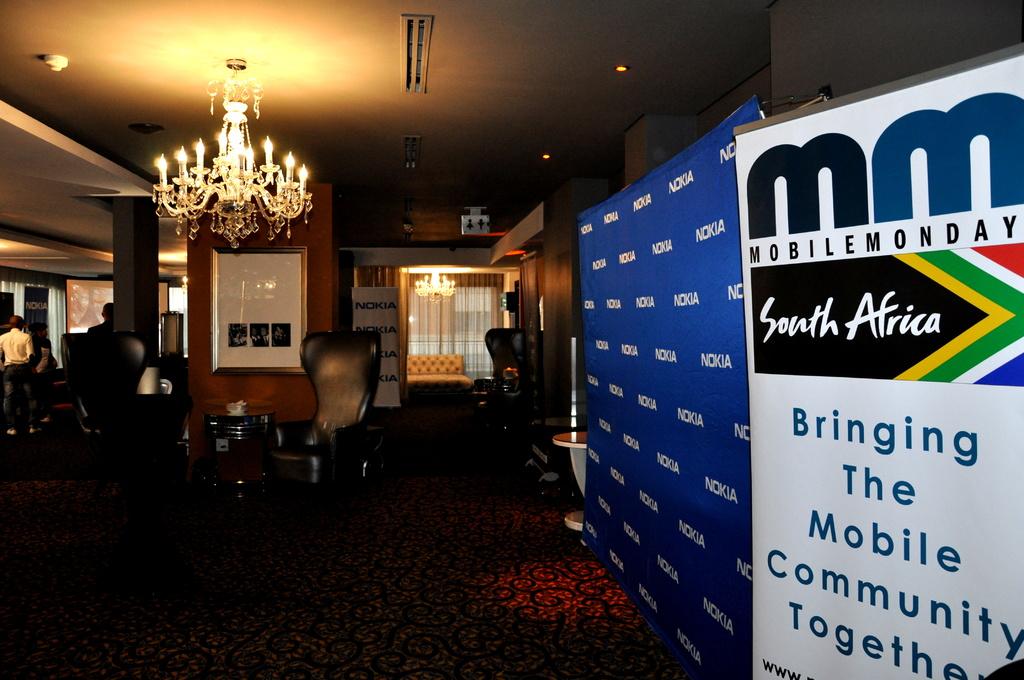What country is this from?
Offer a terse response. South africa. What is the monday called?
Provide a succinct answer. Mobile monday. 